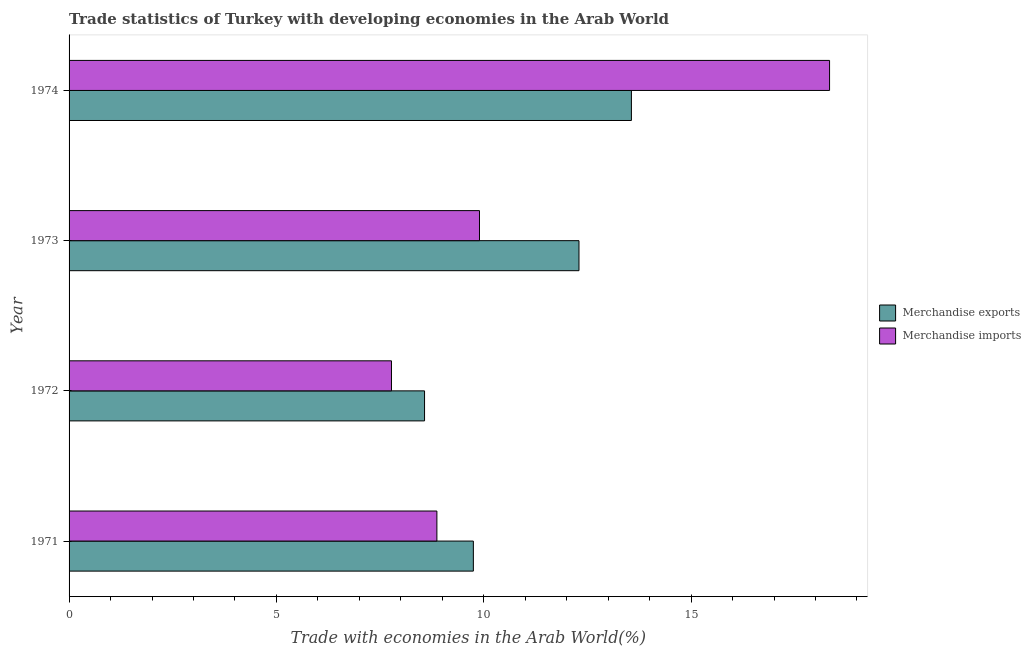How many different coloured bars are there?
Provide a succinct answer. 2. Are the number of bars on each tick of the Y-axis equal?
Provide a succinct answer. Yes. How many bars are there on the 3rd tick from the top?
Your answer should be compact. 2. How many bars are there on the 3rd tick from the bottom?
Your answer should be compact. 2. What is the label of the 3rd group of bars from the top?
Provide a short and direct response. 1972. In how many cases, is the number of bars for a given year not equal to the number of legend labels?
Provide a short and direct response. 0. What is the merchandise imports in 1973?
Your response must be concise. 9.9. Across all years, what is the maximum merchandise exports?
Offer a very short reply. 13.56. Across all years, what is the minimum merchandise exports?
Offer a terse response. 8.57. In which year was the merchandise imports maximum?
Provide a succinct answer. 1974. What is the total merchandise exports in the graph?
Your answer should be very brief. 44.18. What is the difference between the merchandise imports in 1971 and that in 1972?
Provide a short and direct response. 1.09. What is the difference between the merchandise exports in 1971 and the merchandise imports in 1972?
Offer a very short reply. 1.97. What is the average merchandise exports per year?
Make the answer very short. 11.04. In the year 1973, what is the difference between the merchandise imports and merchandise exports?
Your answer should be very brief. -2.4. In how many years, is the merchandise imports greater than 3 %?
Provide a succinct answer. 4. What is the ratio of the merchandise exports in 1972 to that in 1974?
Keep it short and to the point. 0.63. Is the merchandise exports in 1971 less than that in 1972?
Ensure brevity in your answer.  No. Is the difference between the merchandise exports in 1971 and 1973 greater than the difference between the merchandise imports in 1971 and 1973?
Give a very brief answer. No. What is the difference between the highest and the second highest merchandise exports?
Make the answer very short. 1.26. What is the difference between the highest and the lowest merchandise exports?
Give a very brief answer. 4.99. In how many years, is the merchandise imports greater than the average merchandise imports taken over all years?
Offer a terse response. 1. Is the sum of the merchandise imports in 1971 and 1972 greater than the maximum merchandise exports across all years?
Your answer should be compact. Yes. What does the 1st bar from the top in 1972 represents?
Your answer should be very brief. Merchandise imports. What does the 1st bar from the bottom in 1971 represents?
Make the answer very short. Merchandise exports. Are all the bars in the graph horizontal?
Ensure brevity in your answer.  Yes. What is the difference between two consecutive major ticks on the X-axis?
Give a very brief answer. 5. Are the values on the major ticks of X-axis written in scientific E-notation?
Ensure brevity in your answer.  No. Does the graph contain any zero values?
Your answer should be compact. No. Does the graph contain grids?
Your answer should be very brief. No. How many legend labels are there?
Provide a short and direct response. 2. How are the legend labels stacked?
Provide a succinct answer. Vertical. What is the title of the graph?
Keep it short and to the point. Trade statistics of Turkey with developing economies in the Arab World. Does "Under-five" appear as one of the legend labels in the graph?
Give a very brief answer. No. What is the label or title of the X-axis?
Provide a succinct answer. Trade with economies in the Arab World(%). What is the label or title of the Y-axis?
Offer a terse response. Year. What is the Trade with economies in the Arab World(%) of Merchandise exports in 1971?
Make the answer very short. 9.75. What is the Trade with economies in the Arab World(%) of Merchandise imports in 1971?
Give a very brief answer. 8.87. What is the Trade with economies in the Arab World(%) in Merchandise exports in 1972?
Offer a very short reply. 8.57. What is the Trade with economies in the Arab World(%) of Merchandise imports in 1972?
Offer a terse response. 7.77. What is the Trade with economies in the Arab World(%) in Merchandise exports in 1973?
Offer a very short reply. 12.3. What is the Trade with economies in the Arab World(%) in Merchandise imports in 1973?
Ensure brevity in your answer.  9.9. What is the Trade with economies in the Arab World(%) of Merchandise exports in 1974?
Ensure brevity in your answer.  13.56. What is the Trade with economies in the Arab World(%) of Merchandise imports in 1974?
Provide a short and direct response. 18.34. Across all years, what is the maximum Trade with economies in the Arab World(%) of Merchandise exports?
Offer a terse response. 13.56. Across all years, what is the maximum Trade with economies in the Arab World(%) of Merchandise imports?
Give a very brief answer. 18.34. Across all years, what is the minimum Trade with economies in the Arab World(%) in Merchandise exports?
Your response must be concise. 8.57. Across all years, what is the minimum Trade with economies in the Arab World(%) of Merchandise imports?
Your answer should be compact. 7.77. What is the total Trade with economies in the Arab World(%) in Merchandise exports in the graph?
Make the answer very short. 44.18. What is the total Trade with economies in the Arab World(%) of Merchandise imports in the graph?
Make the answer very short. 44.88. What is the difference between the Trade with economies in the Arab World(%) of Merchandise exports in 1971 and that in 1972?
Give a very brief answer. 1.18. What is the difference between the Trade with economies in the Arab World(%) in Merchandise imports in 1971 and that in 1972?
Your response must be concise. 1.1. What is the difference between the Trade with economies in the Arab World(%) of Merchandise exports in 1971 and that in 1973?
Give a very brief answer. -2.55. What is the difference between the Trade with economies in the Arab World(%) of Merchandise imports in 1971 and that in 1973?
Keep it short and to the point. -1.03. What is the difference between the Trade with economies in the Arab World(%) of Merchandise exports in 1971 and that in 1974?
Offer a terse response. -3.81. What is the difference between the Trade with economies in the Arab World(%) in Merchandise imports in 1971 and that in 1974?
Your response must be concise. -9.47. What is the difference between the Trade with economies in the Arab World(%) in Merchandise exports in 1972 and that in 1973?
Ensure brevity in your answer.  -3.72. What is the difference between the Trade with economies in the Arab World(%) in Merchandise imports in 1972 and that in 1973?
Provide a succinct answer. -2.12. What is the difference between the Trade with economies in the Arab World(%) in Merchandise exports in 1972 and that in 1974?
Ensure brevity in your answer.  -4.99. What is the difference between the Trade with economies in the Arab World(%) of Merchandise imports in 1972 and that in 1974?
Your answer should be compact. -10.56. What is the difference between the Trade with economies in the Arab World(%) of Merchandise exports in 1973 and that in 1974?
Your response must be concise. -1.26. What is the difference between the Trade with economies in the Arab World(%) in Merchandise imports in 1973 and that in 1974?
Provide a short and direct response. -8.44. What is the difference between the Trade with economies in the Arab World(%) of Merchandise exports in 1971 and the Trade with economies in the Arab World(%) of Merchandise imports in 1972?
Provide a short and direct response. 1.97. What is the difference between the Trade with economies in the Arab World(%) in Merchandise exports in 1971 and the Trade with economies in the Arab World(%) in Merchandise imports in 1973?
Ensure brevity in your answer.  -0.15. What is the difference between the Trade with economies in the Arab World(%) of Merchandise exports in 1971 and the Trade with economies in the Arab World(%) of Merchandise imports in 1974?
Give a very brief answer. -8.59. What is the difference between the Trade with economies in the Arab World(%) of Merchandise exports in 1972 and the Trade with economies in the Arab World(%) of Merchandise imports in 1973?
Your answer should be compact. -1.32. What is the difference between the Trade with economies in the Arab World(%) in Merchandise exports in 1972 and the Trade with economies in the Arab World(%) in Merchandise imports in 1974?
Provide a succinct answer. -9.77. What is the difference between the Trade with economies in the Arab World(%) in Merchandise exports in 1973 and the Trade with economies in the Arab World(%) in Merchandise imports in 1974?
Make the answer very short. -6.04. What is the average Trade with economies in the Arab World(%) in Merchandise exports per year?
Provide a succinct answer. 11.04. What is the average Trade with economies in the Arab World(%) in Merchandise imports per year?
Your answer should be very brief. 11.22. In the year 1971, what is the difference between the Trade with economies in the Arab World(%) of Merchandise exports and Trade with economies in the Arab World(%) of Merchandise imports?
Provide a succinct answer. 0.88. In the year 1972, what is the difference between the Trade with economies in the Arab World(%) of Merchandise exports and Trade with economies in the Arab World(%) of Merchandise imports?
Provide a succinct answer. 0.8. In the year 1973, what is the difference between the Trade with economies in the Arab World(%) in Merchandise exports and Trade with economies in the Arab World(%) in Merchandise imports?
Your answer should be compact. 2.4. In the year 1974, what is the difference between the Trade with economies in the Arab World(%) in Merchandise exports and Trade with economies in the Arab World(%) in Merchandise imports?
Ensure brevity in your answer.  -4.78. What is the ratio of the Trade with economies in the Arab World(%) of Merchandise exports in 1971 to that in 1972?
Give a very brief answer. 1.14. What is the ratio of the Trade with economies in the Arab World(%) in Merchandise imports in 1971 to that in 1972?
Give a very brief answer. 1.14. What is the ratio of the Trade with economies in the Arab World(%) in Merchandise exports in 1971 to that in 1973?
Your response must be concise. 0.79. What is the ratio of the Trade with economies in the Arab World(%) of Merchandise imports in 1971 to that in 1973?
Make the answer very short. 0.9. What is the ratio of the Trade with economies in the Arab World(%) in Merchandise exports in 1971 to that in 1974?
Your answer should be very brief. 0.72. What is the ratio of the Trade with economies in the Arab World(%) of Merchandise imports in 1971 to that in 1974?
Give a very brief answer. 0.48. What is the ratio of the Trade with economies in the Arab World(%) in Merchandise exports in 1972 to that in 1973?
Your answer should be compact. 0.7. What is the ratio of the Trade with economies in the Arab World(%) of Merchandise imports in 1972 to that in 1973?
Your answer should be compact. 0.79. What is the ratio of the Trade with economies in the Arab World(%) of Merchandise exports in 1972 to that in 1974?
Keep it short and to the point. 0.63. What is the ratio of the Trade with economies in the Arab World(%) of Merchandise imports in 1972 to that in 1974?
Your answer should be compact. 0.42. What is the ratio of the Trade with economies in the Arab World(%) in Merchandise exports in 1973 to that in 1974?
Make the answer very short. 0.91. What is the ratio of the Trade with economies in the Arab World(%) of Merchandise imports in 1973 to that in 1974?
Offer a terse response. 0.54. What is the difference between the highest and the second highest Trade with economies in the Arab World(%) in Merchandise exports?
Provide a short and direct response. 1.26. What is the difference between the highest and the second highest Trade with economies in the Arab World(%) of Merchandise imports?
Offer a terse response. 8.44. What is the difference between the highest and the lowest Trade with economies in the Arab World(%) in Merchandise exports?
Ensure brevity in your answer.  4.99. What is the difference between the highest and the lowest Trade with economies in the Arab World(%) in Merchandise imports?
Give a very brief answer. 10.56. 